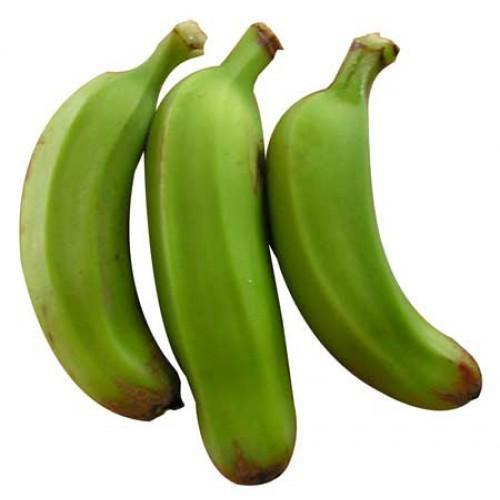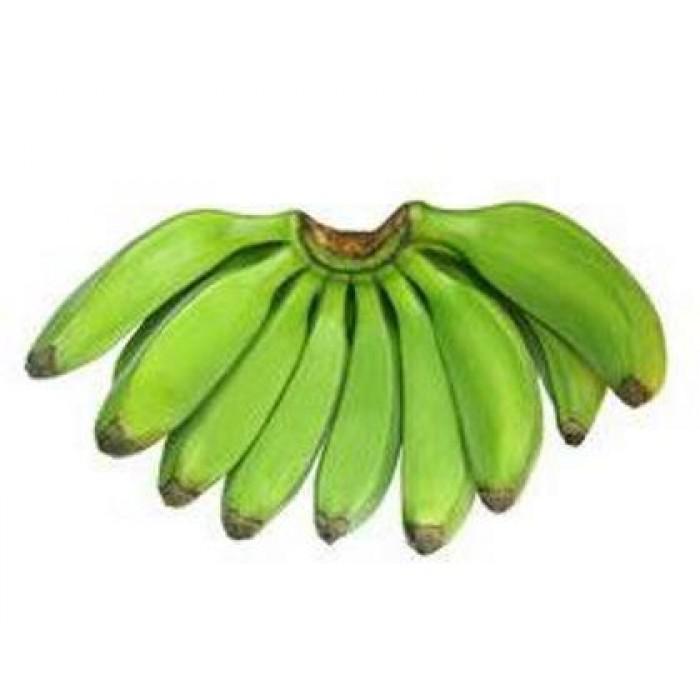The first image is the image on the left, the second image is the image on the right. Assess this claim about the two images: "One of the images is exactly three green bananas, and this particular bunch is not connected.". Correct or not? Answer yes or no. Yes. 